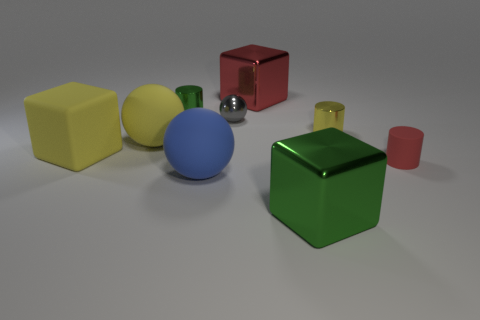Can you tell me how many objects there are and which one is the largest? In total, there are six objects in the image. The green cube is the largest one among them, easily noticeable by comparing its size relative to the surrounding objects. 